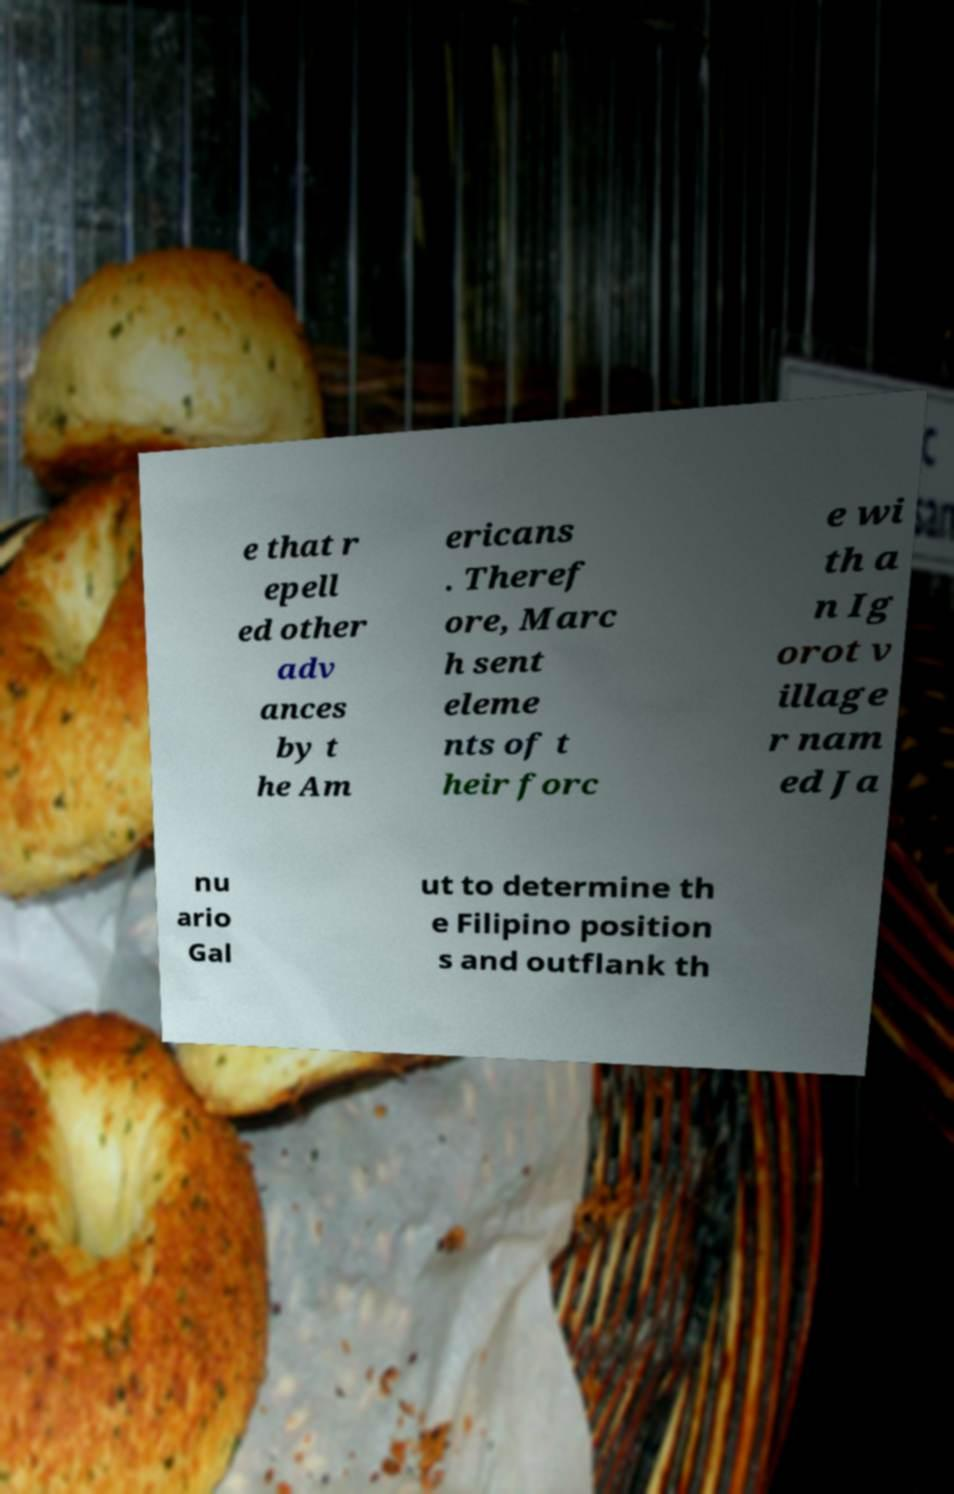For documentation purposes, I need the text within this image transcribed. Could you provide that? e that r epell ed other adv ances by t he Am ericans . Theref ore, Marc h sent eleme nts of t heir forc e wi th a n Ig orot v illage r nam ed Ja nu ario Gal ut to determine th e Filipino position s and outflank th 